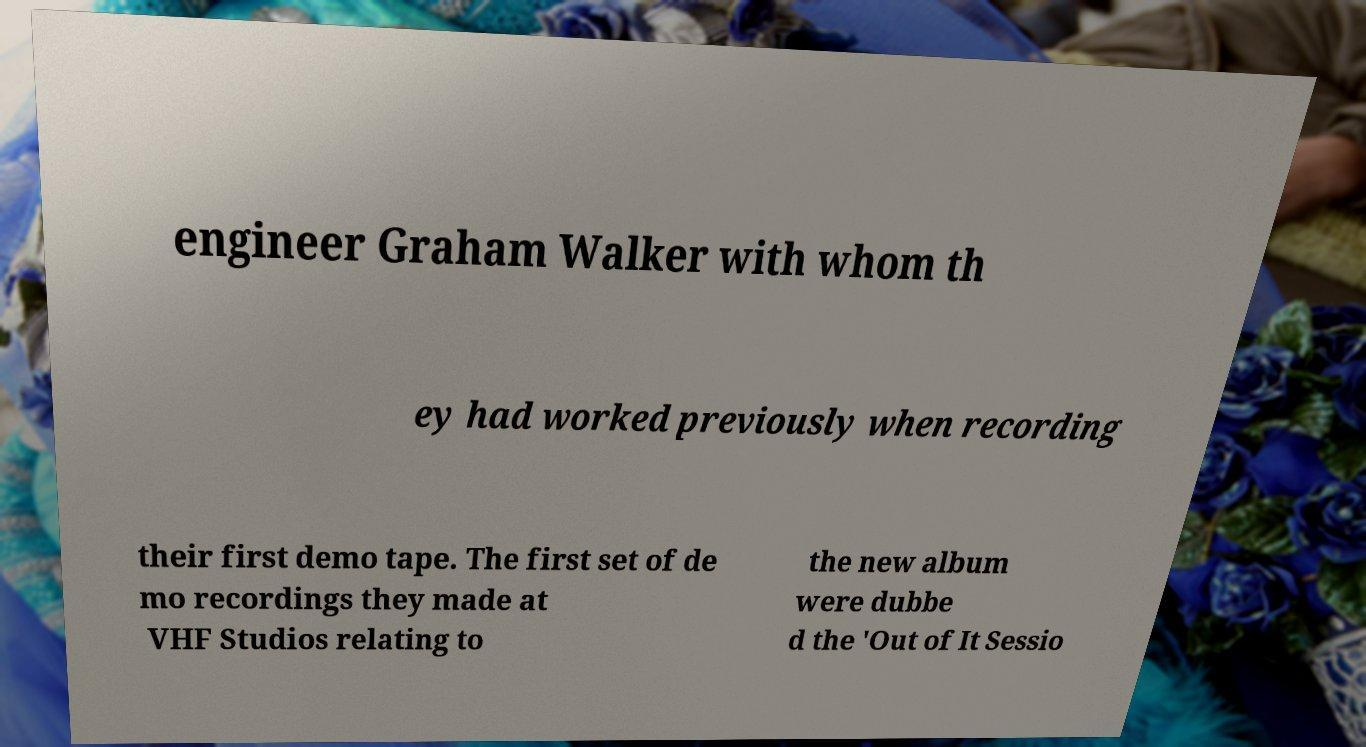Can you read and provide the text displayed in the image?This photo seems to have some interesting text. Can you extract and type it out for me? engineer Graham Walker with whom th ey had worked previously when recording their first demo tape. The first set of de mo recordings they made at VHF Studios relating to the new album were dubbe d the 'Out of It Sessio 